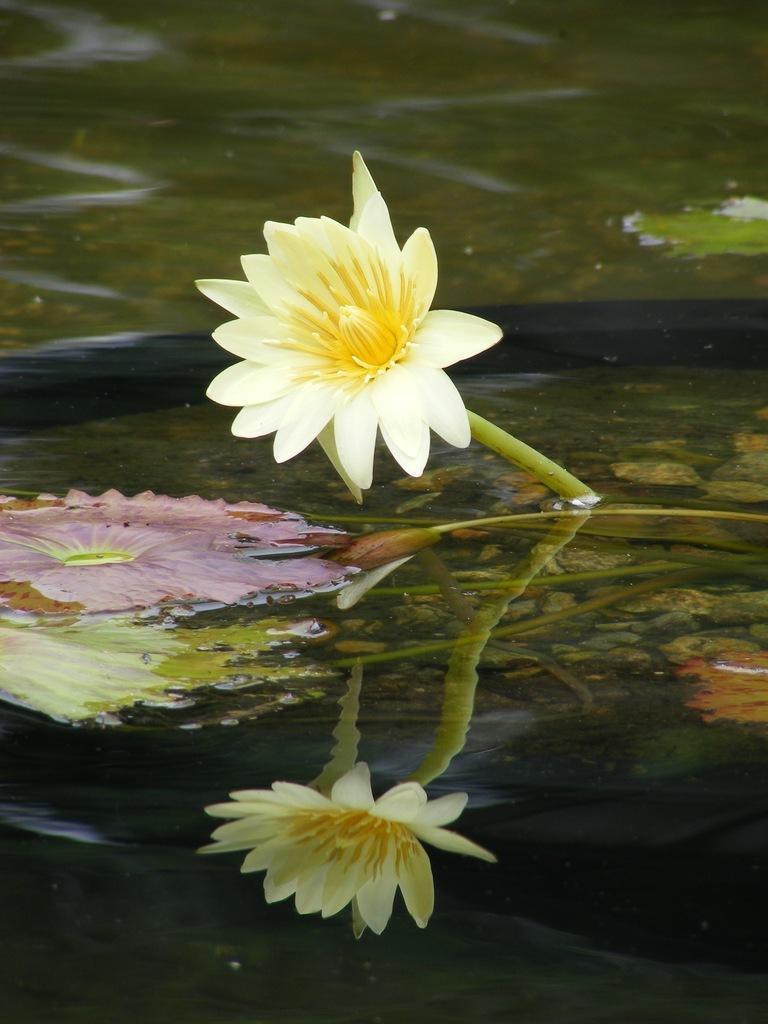Describe this image in one or two sentences. In this image we can see the flower in the water. Here we can see the reflection of the flowers in the water. 